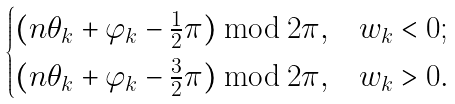Convert formula to latex. <formula><loc_0><loc_0><loc_500><loc_500>\begin{cases} ( n \theta _ { k } + \varphi _ { k } - \frac { 1 } { 2 } \pi ) \bmod 2 \pi , & w _ { k } < 0 ; \\ ( n \theta _ { k } + \varphi _ { k } - \frac { 3 } { 2 } \pi ) \bmod 2 \pi , & w _ { k } > 0 . \end{cases}</formula> 